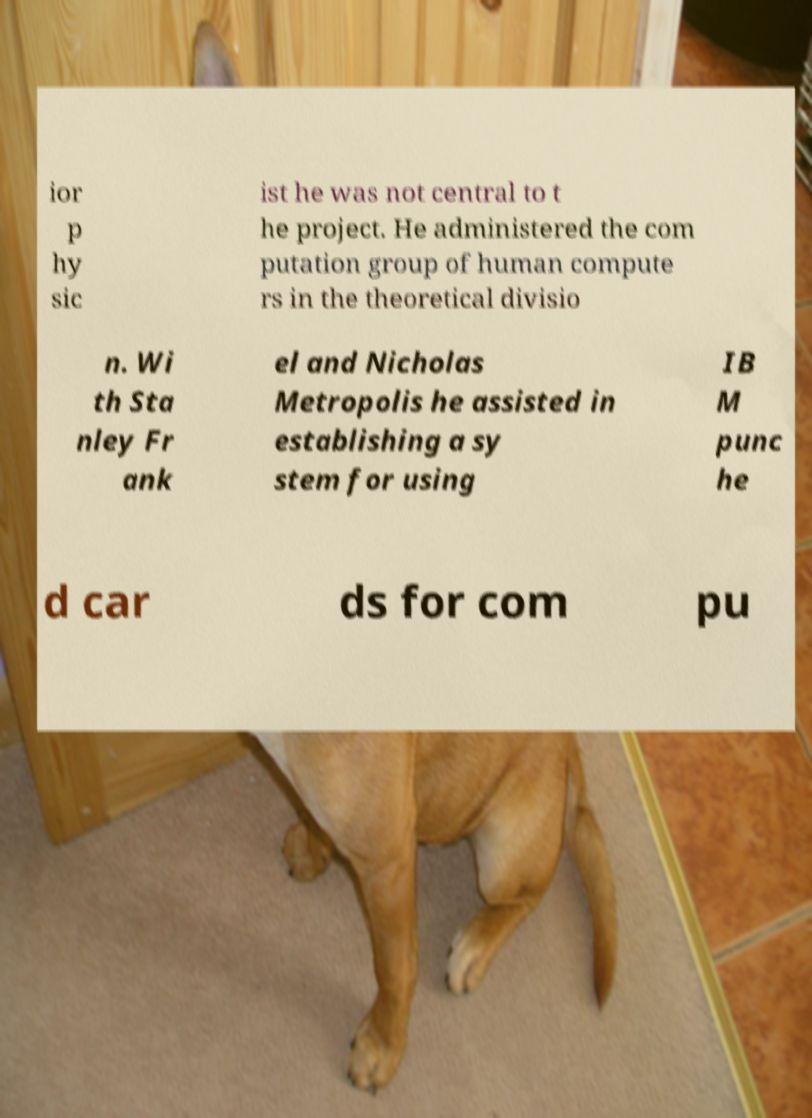There's text embedded in this image that I need extracted. Can you transcribe it verbatim? ior p hy sic ist he was not central to t he project. He administered the com putation group of human compute rs in the theoretical divisio n. Wi th Sta nley Fr ank el and Nicholas Metropolis he assisted in establishing a sy stem for using IB M punc he d car ds for com pu 